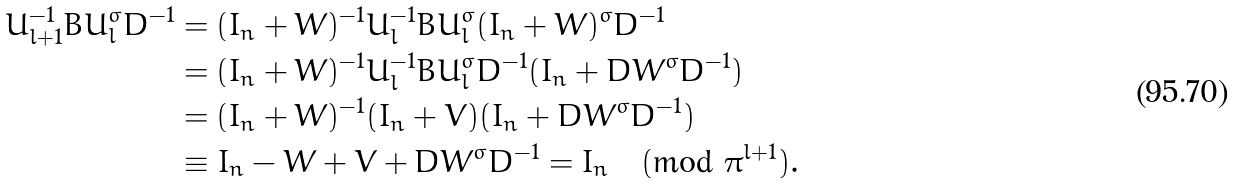<formula> <loc_0><loc_0><loc_500><loc_500>U _ { l + 1 } ^ { - 1 } B U _ { l } ^ { \sigma } D ^ { - 1 } & = ( I _ { n } + W ) ^ { - 1 } U _ { l } ^ { - 1 } B U _ { l } ^ { \sigma } ( I _ { n } + W ) ^ { \sigma } D ^ { - 1 } \\ & = ( I _ { n } + W ) ^ { - 1 } U _ { l } ^ { - 1 } B U _ { l } ^ { \sigma } D ^ { - 1 } ( I _ { n } + D W ^ { \sigma } D ^ { - 1 } ) \\ & = ( I _ { n } + W ) ^ { - 1 } ( I _ { n } + V ) ( I _ { n } + D W ^ { \sigma } D ^ { - 1 } ) \\ & \equiv I _ { n } - W + V + D W ^ { \sigma } D ^ { - 1 } = I _ { n } \pmod { \pi ^ { l + 1 } } .</formula> 